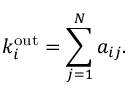Convert formula to latex. <formula><loc_0><loc_0><loc_500><loc_500>k _ { i } ^ { { \mathrm { o u t } } } = \sum _ { j = 1 } ^ { N } a _ { i j } .</formula> 